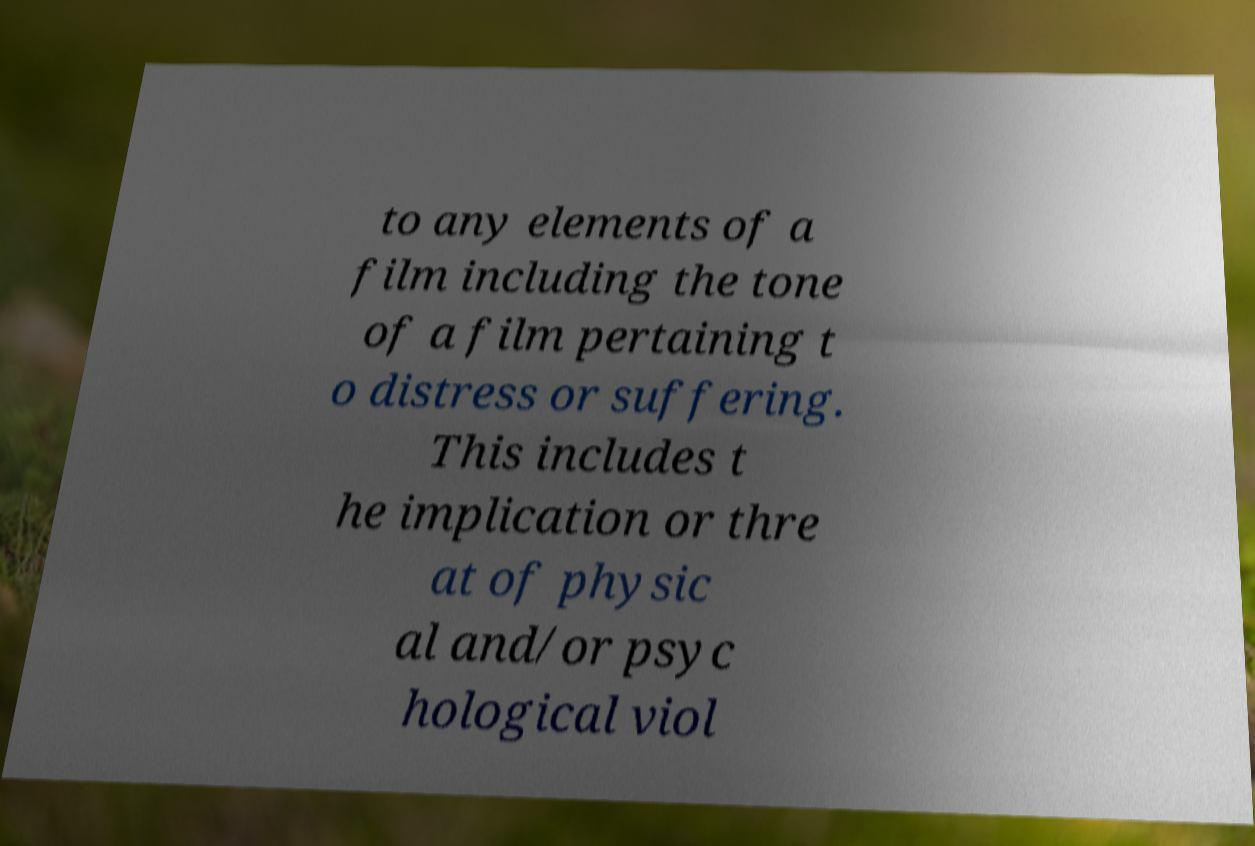Please read and relay the text visible in this image. What does it say? to any elements of a film including the tone of a film pertaining t o distress or suffering. This includes t he implication or thre at of physic al and/or psyc hological viol 